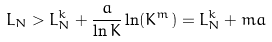Convert formula to latex. <formula><loc_0><loc_0><loc_500><loc_500>L _ { N } > L _ { N } ^ { k } + \frac { a } { \ln K } \ln ( K ^ { m } ) = L _ { N } ^ { k } + m a</formula> 